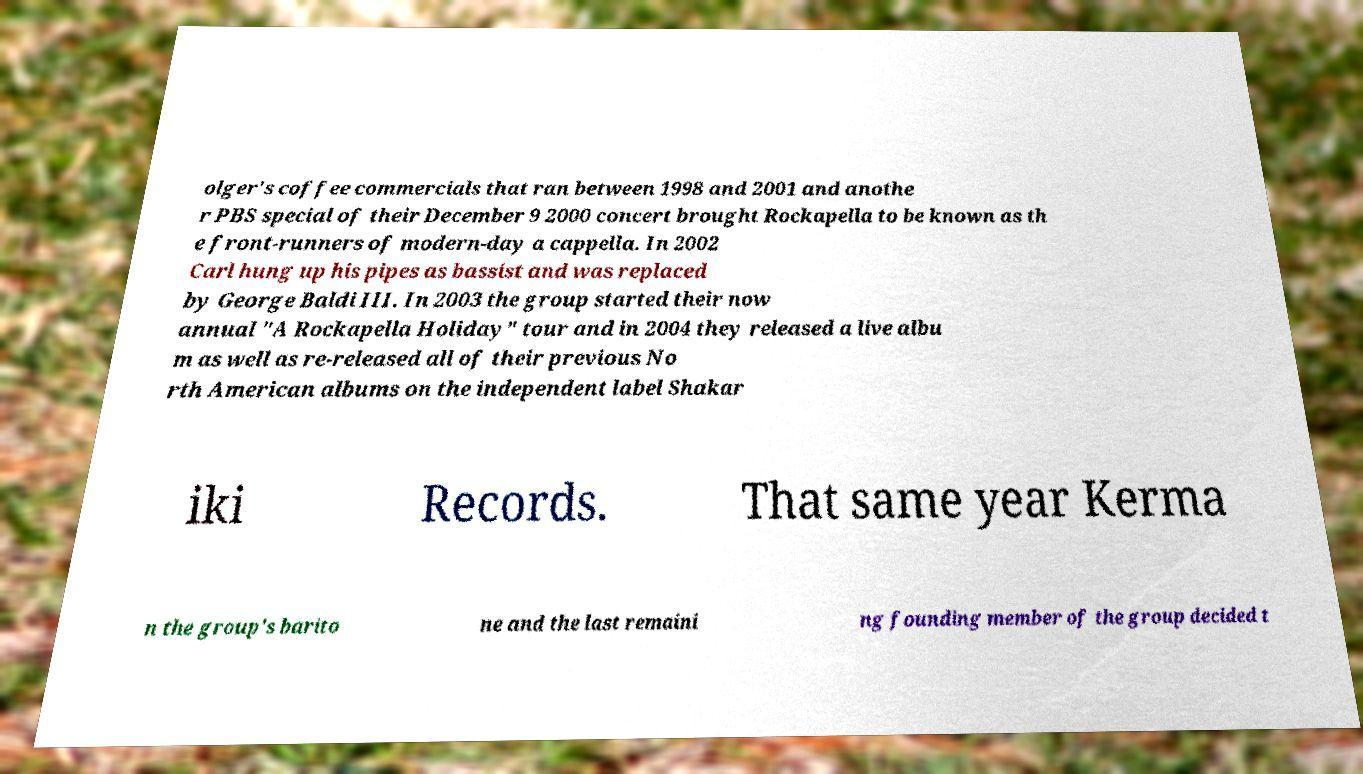Could you assist in decoding the text presented in this image and type it out clearly? olger's coffee commercials that ran between 1998 and 2001 and anothe r PBS special of their December 9 2000 concert brought Rockapella to be known as th e front-runners of modern-day a cappella. In 2002 Carl hung up his pipes as bassist and was replaced by George Baldi III. In 2003 the group started their now annual "A Rockapella Holiday" tour and in 2004 they released a live albu m as well as re-released all of their previous No rth American albums on the independent label Shakar iki Records. That same year Kerma n the group's barito ne and the last remaini ng founding member of the group decided t 